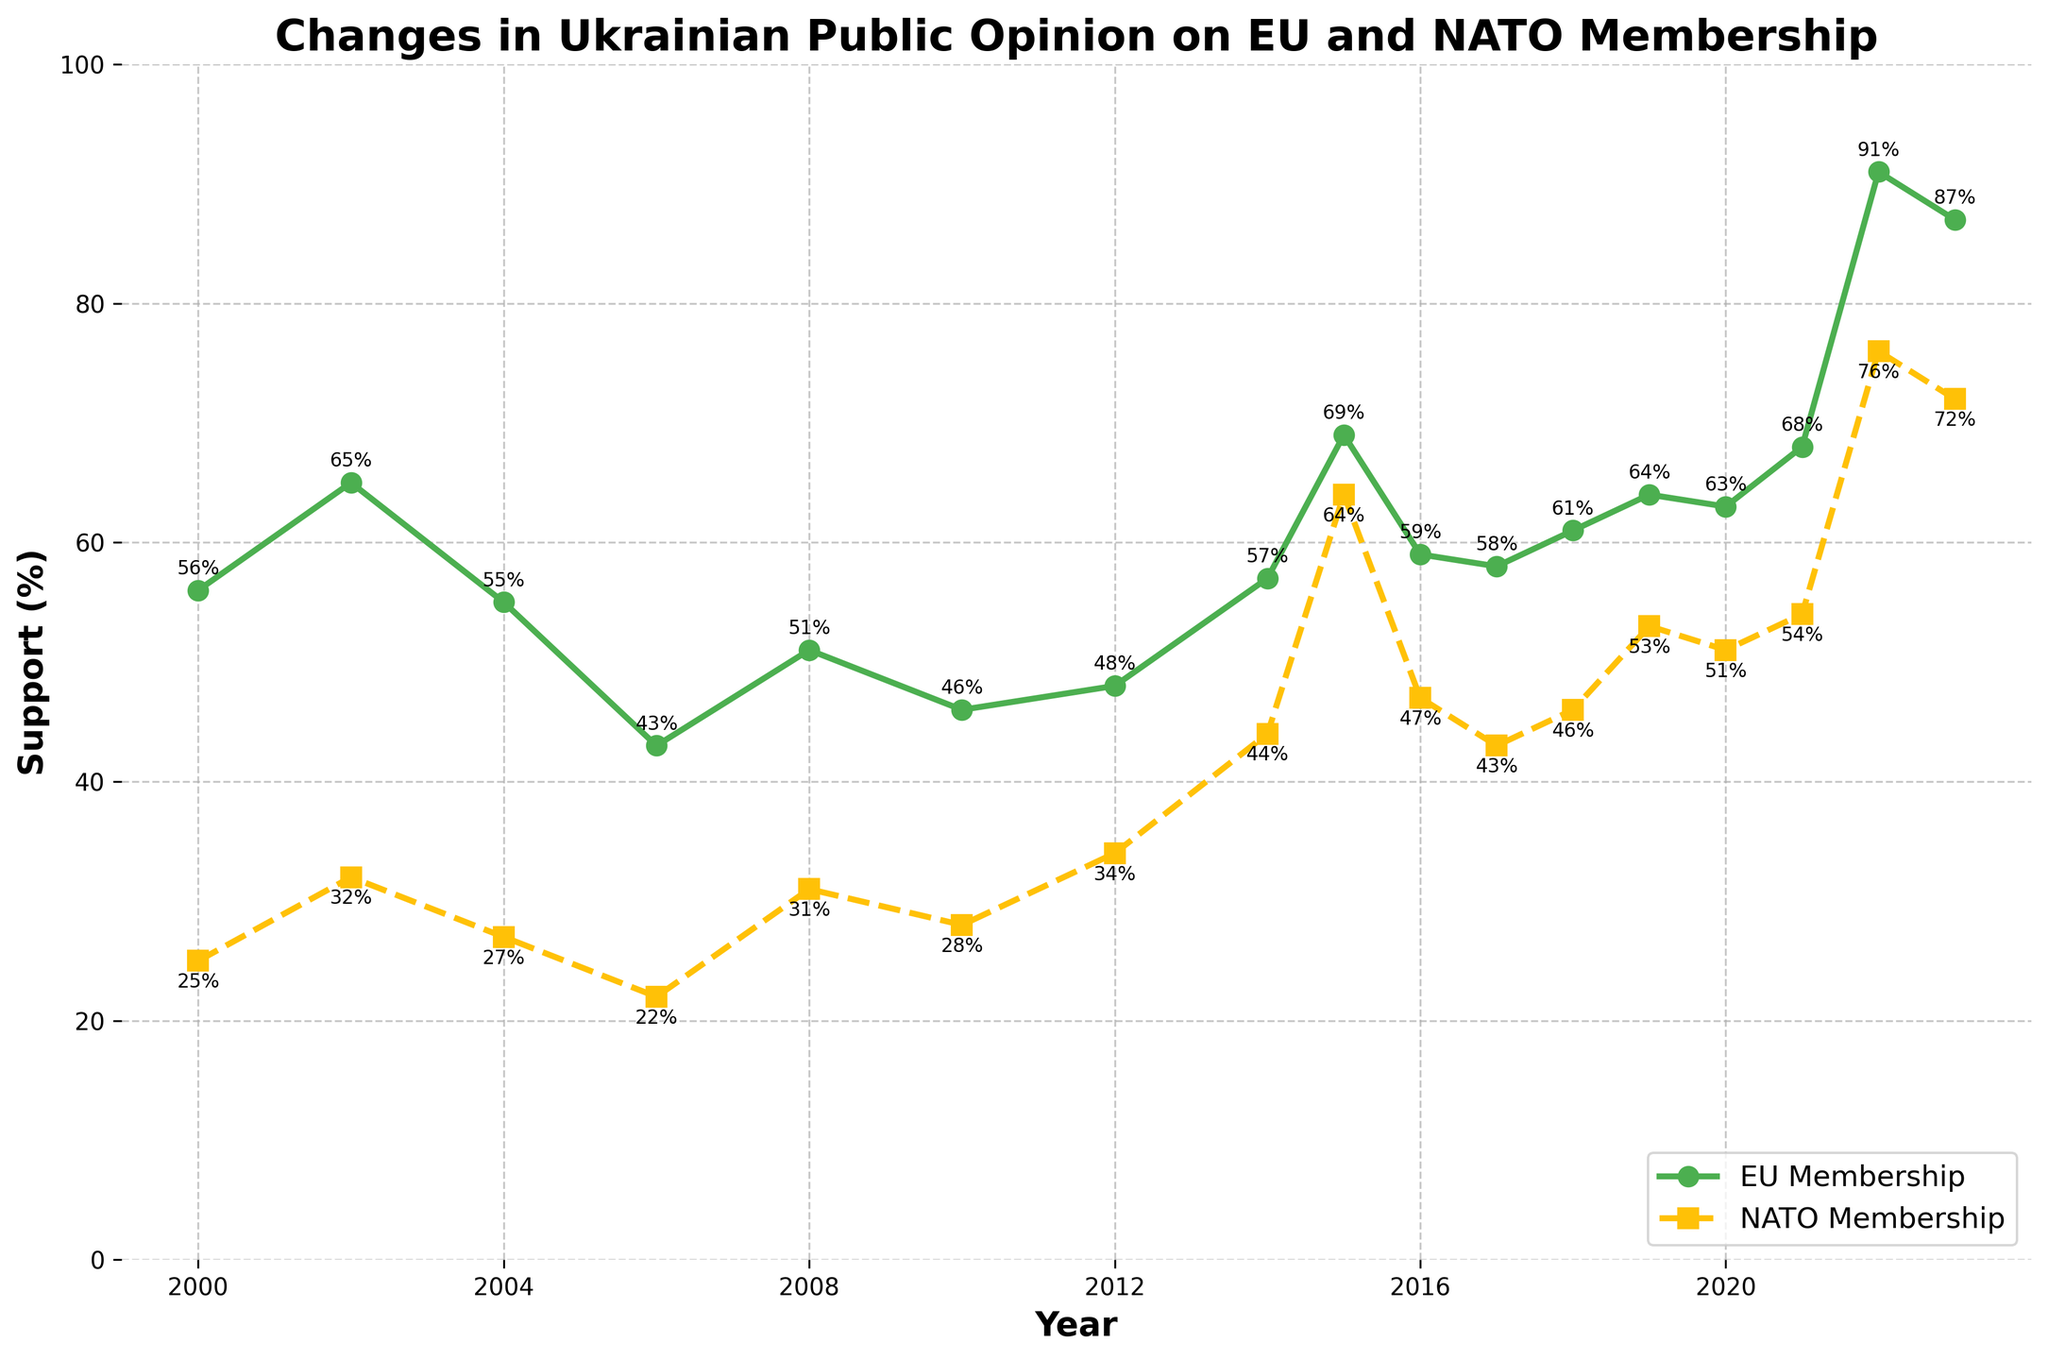What is the year with the highest support for EU membership? Look at the EU membership line (green) on the chart and identify the year where the line reaches its highest point. This is the highest data point on the green line.
Answer: 2022 What was the difference in support for NATO membership between 2012 and 2015? Find the support percentage in 2012 and 2015 for NATO membership on the chart and calculate the difference (64% - 34%).
Answer: 30% Which year had a greater increase in support for NATO membership compared to the previous year: 2014 to 2015 or 2021 to 2022? Look at the NATO support line (yellow) and compare the increase from 2014 (44%) to 2015 (64%) and from 2021 (54%) to 2022 (76%). Calculate the differences (64%-44% = 20% and 76%-54% = 22%).
Answer: 2021 to 2022 What is the average support for EU membership over the first five recorded years? Sum the EU membership support percentages for the years 2000, 2002, 2004, 2006, and 2008, then divide by 5: (56 + 65 + 55 + 43 + 51) / 5.
Answer: 54% In which year did the support for NATO membership first surpass 50%? Observe the NATO support line (yellow) and identify the year where the support percentage exceeds 50% for the first time. Check from left to right until you reach the first point over 50%.
Answer: 2015 During which year was the difference between support for EU membership and NATO membership the smallest? Compute the difference for each year by subtracting NATO support from EU support and find the smallest value. The differences should be similar, so check visually or calculate precise gaps if needed: e.g., 2015 (69-64=5), 2022 (91-76=15). The smallest difference is in 2022.
Answer: 2022 How many years did EU membership support stay above 60%? Identify the years where the EU membership support (green line) is above the 60% mark by counting the total. The years are: 2002, 2019, 2021, 2022, 2023.
Answer: 5 Between 2000 and 2008, which type of membership received highest public support, EU or NATO? Compare the heights of the green and yellow lines over the years 2000 to 2008. EU support (green line) is consistently higher in this period.
Answer: EU What is the trend in support for NATO membership from 2010 to 2023? Follow the yellow line from 2010 to 2023 and describe its behavior. It generally trends upwards with some fluctuations.
Answer: Upward trend How does the support for EU and NATO memberships in 2014 compare to that in 2012? Compare the support percentages in 2014 (EU: 57%, NATO: 44%) with those in 2012 (EU: 48%, NATO: 34%) by evaluating whether they increased or decreased. Both have increased; EU by 9% and NATO by 10%.
Answer: Both increased 